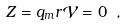<formula> <loc_0><loc_0><loc_500><loc_500>Z = q _ { m } r \mathcal { V } = 0 \ ,</formula> 